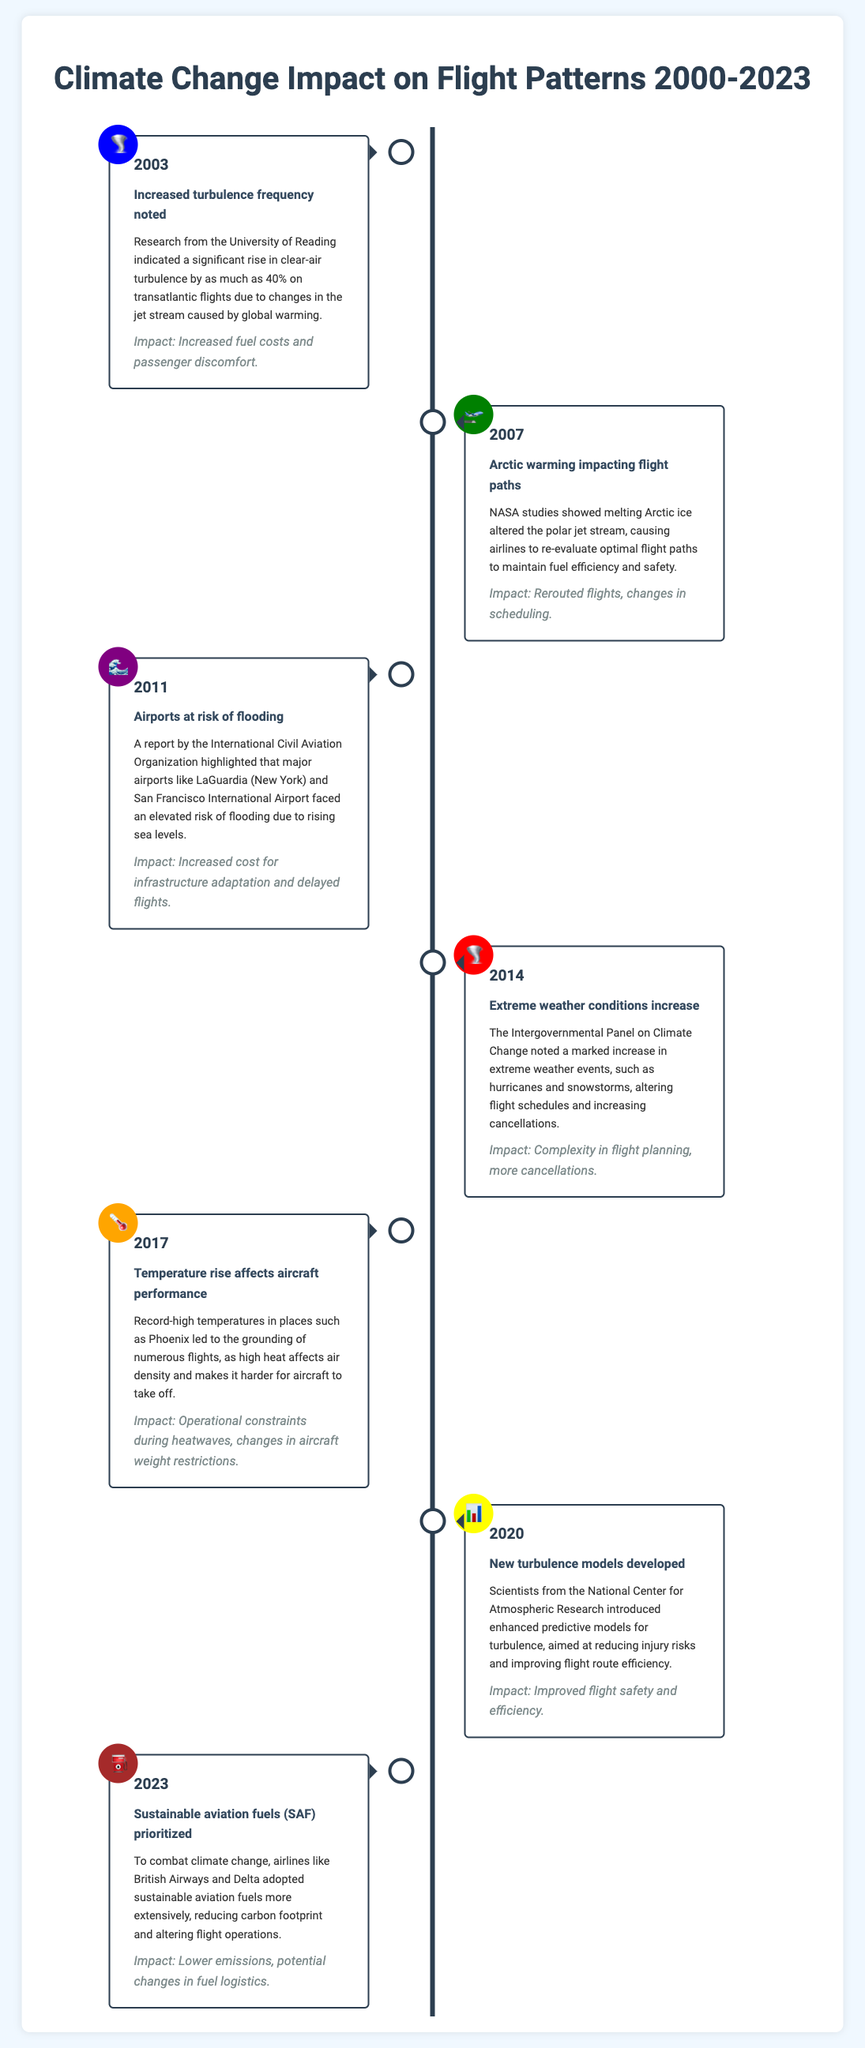What year noted an increase in turbulence frequency? The year that noted an increase in turbulence frequency was highlighted in the document under the event title "Increased turbulence frequency noted."
Answer: 2003 What weather-related incidents increased dramatically in 2014? The document discusses "Extreme weather conditions increase" in 2014, indicating a significant rise in weather events affecting flights.
Answer: Extreme weather conditions Which major airports are mentioned as at risk for flooding? The document specifies major airports at risk of flooding in the event titled "Airports at risk of flooding."
Answer: LaGuardia and San Francisco International Airport What was a consequence of the temperature rise in 2017? The event titled "Temperature rise affects aircraft performance" indicates a specific consequence related to aircraft operations during high heat.
Answer: Grounding of numerous flights What significant modeling advancement occurred in 2020? The event from 2020 discusses the development of new models in relation to turbulence, aimed at enhancing flight safety and efficiency.
Answer: New turbulence models Which year did airlines prioritize sustainable aviation fuels? The title "Sustainable aviation fuels (SAF) prioritized" indicates the specific year when this shift in fuel usage was emphasized.
Answer: 2023 How much clearer is clear-air turbulence noted in 2003? The document indicates a specific percentage increase in clear-air turbulence reported in 2003.
Answer: 40% What type of icon is used for the event in 2020? The event in 2020 refers to a specific icon that relates to the advancements made in turbulence modeling, noted in its description.
Answer: 📊 